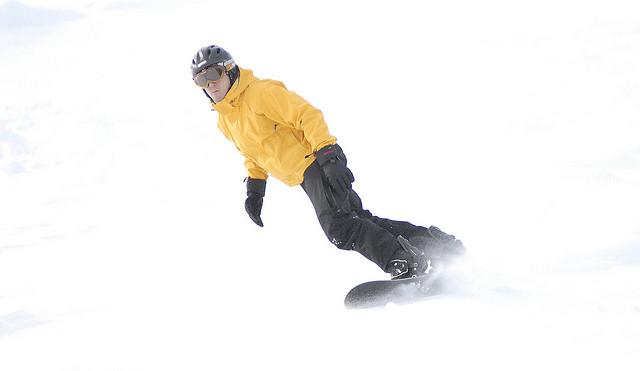What does the man have covering his eyes?
Short answer required. Goggles. What color are his gloves?
Short answer required. Black. Is this man on the snowboard riding on snow?
Quick response, please. Yes. Can the animal swim?
Concise answer only. Yes. 